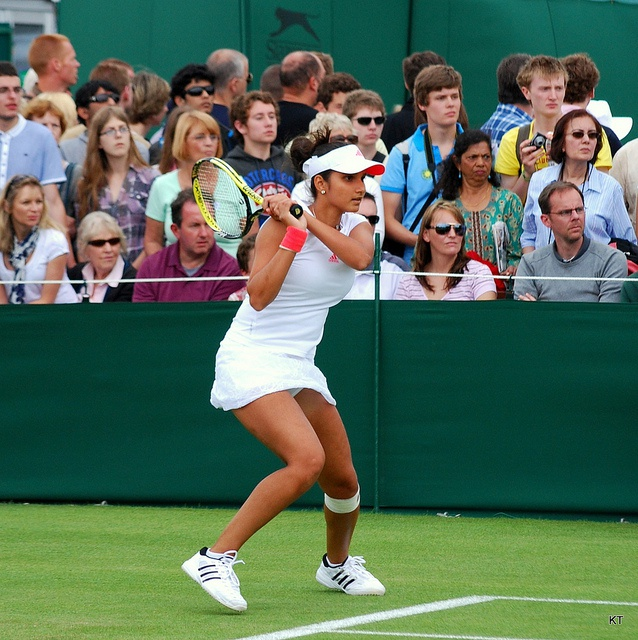Describe the objects in this image and their specific colors. I can see people in gray, black, brown, and maroon tones, people in gray, white, brown, salmon, and maroon tones, people in gray, darkgray, lavender, black, and lightblue tones, people in gray, lightblue, black, brown, and maroon tones, and people in gray, lavender, brown, darkgray, and black tones in this image. 